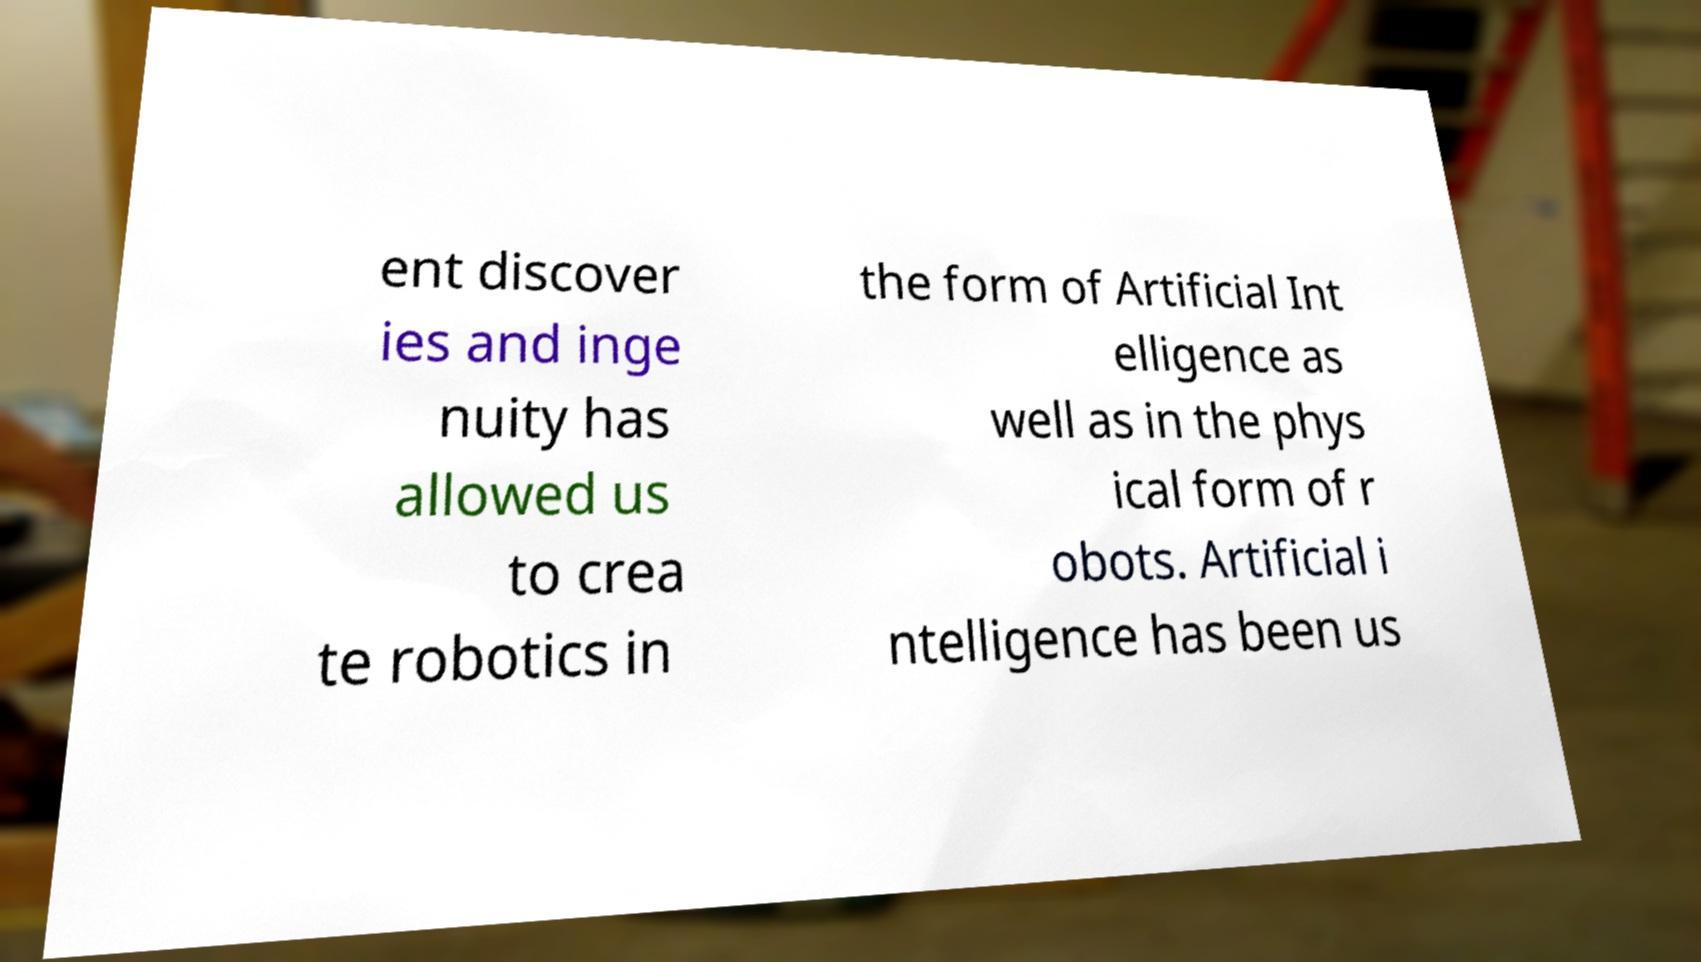Could you assist in decoding the text presented in this image and type it out clearly? ent discover ies and inge nuity has allowed us to crea te robotics in the form of Artificial Int elligence as well as in the phys ical form of r obots. Artificial i ntelligence has been us 